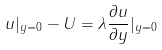Convert formula to latex. <formula><loc_0><loc_0><loc_500><loc_500>u | _ { y = 0 } - U = \lambda \frac { \partial u } { \partial y } | _ { y = 0 }</formula> 